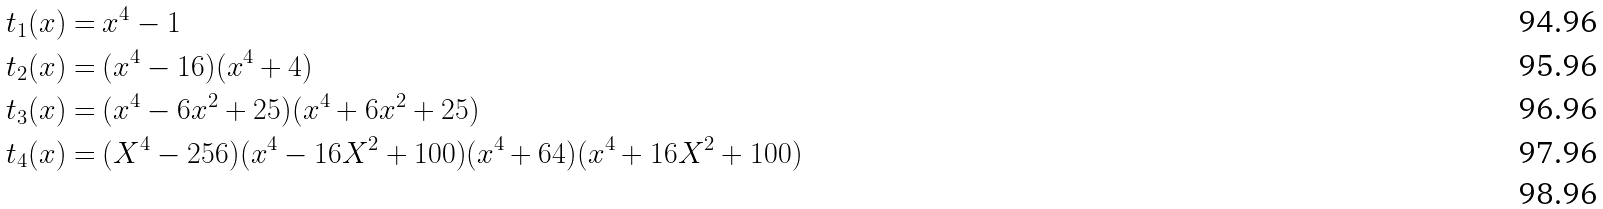Convert formula to latex. <formula><loc_0><loc_0><loc_500><loc_500>t _ { 1 } ( x ) = & \ x ^ { 4 } - 1 \\ t _ { 2 } ( x ) = & \ ( x ^ { 4 } - 1 6 ) ( x ^ { 4 } + 4 ) \\ t _ { 3 } ( x ) = & \ ( x ^ { 4 } - 6 x ^ { 2 } + 2 5 ) ( x ^ { 4 } + 6 x ^ { 2 } + 2 5 ) \\ t _ { 4 } ( x ) = & \ ( X ^ { 4 } - 2 5 6 ) ( x ^ { 4 } - 1 6 X ^ { 2 } + 1 0 0 ) ( x ^ { 4 } + 6 4 ) ( x ^ { 4 } + 1 6 X ^ { 2 } + 1 0 0 ) \\</formula> 